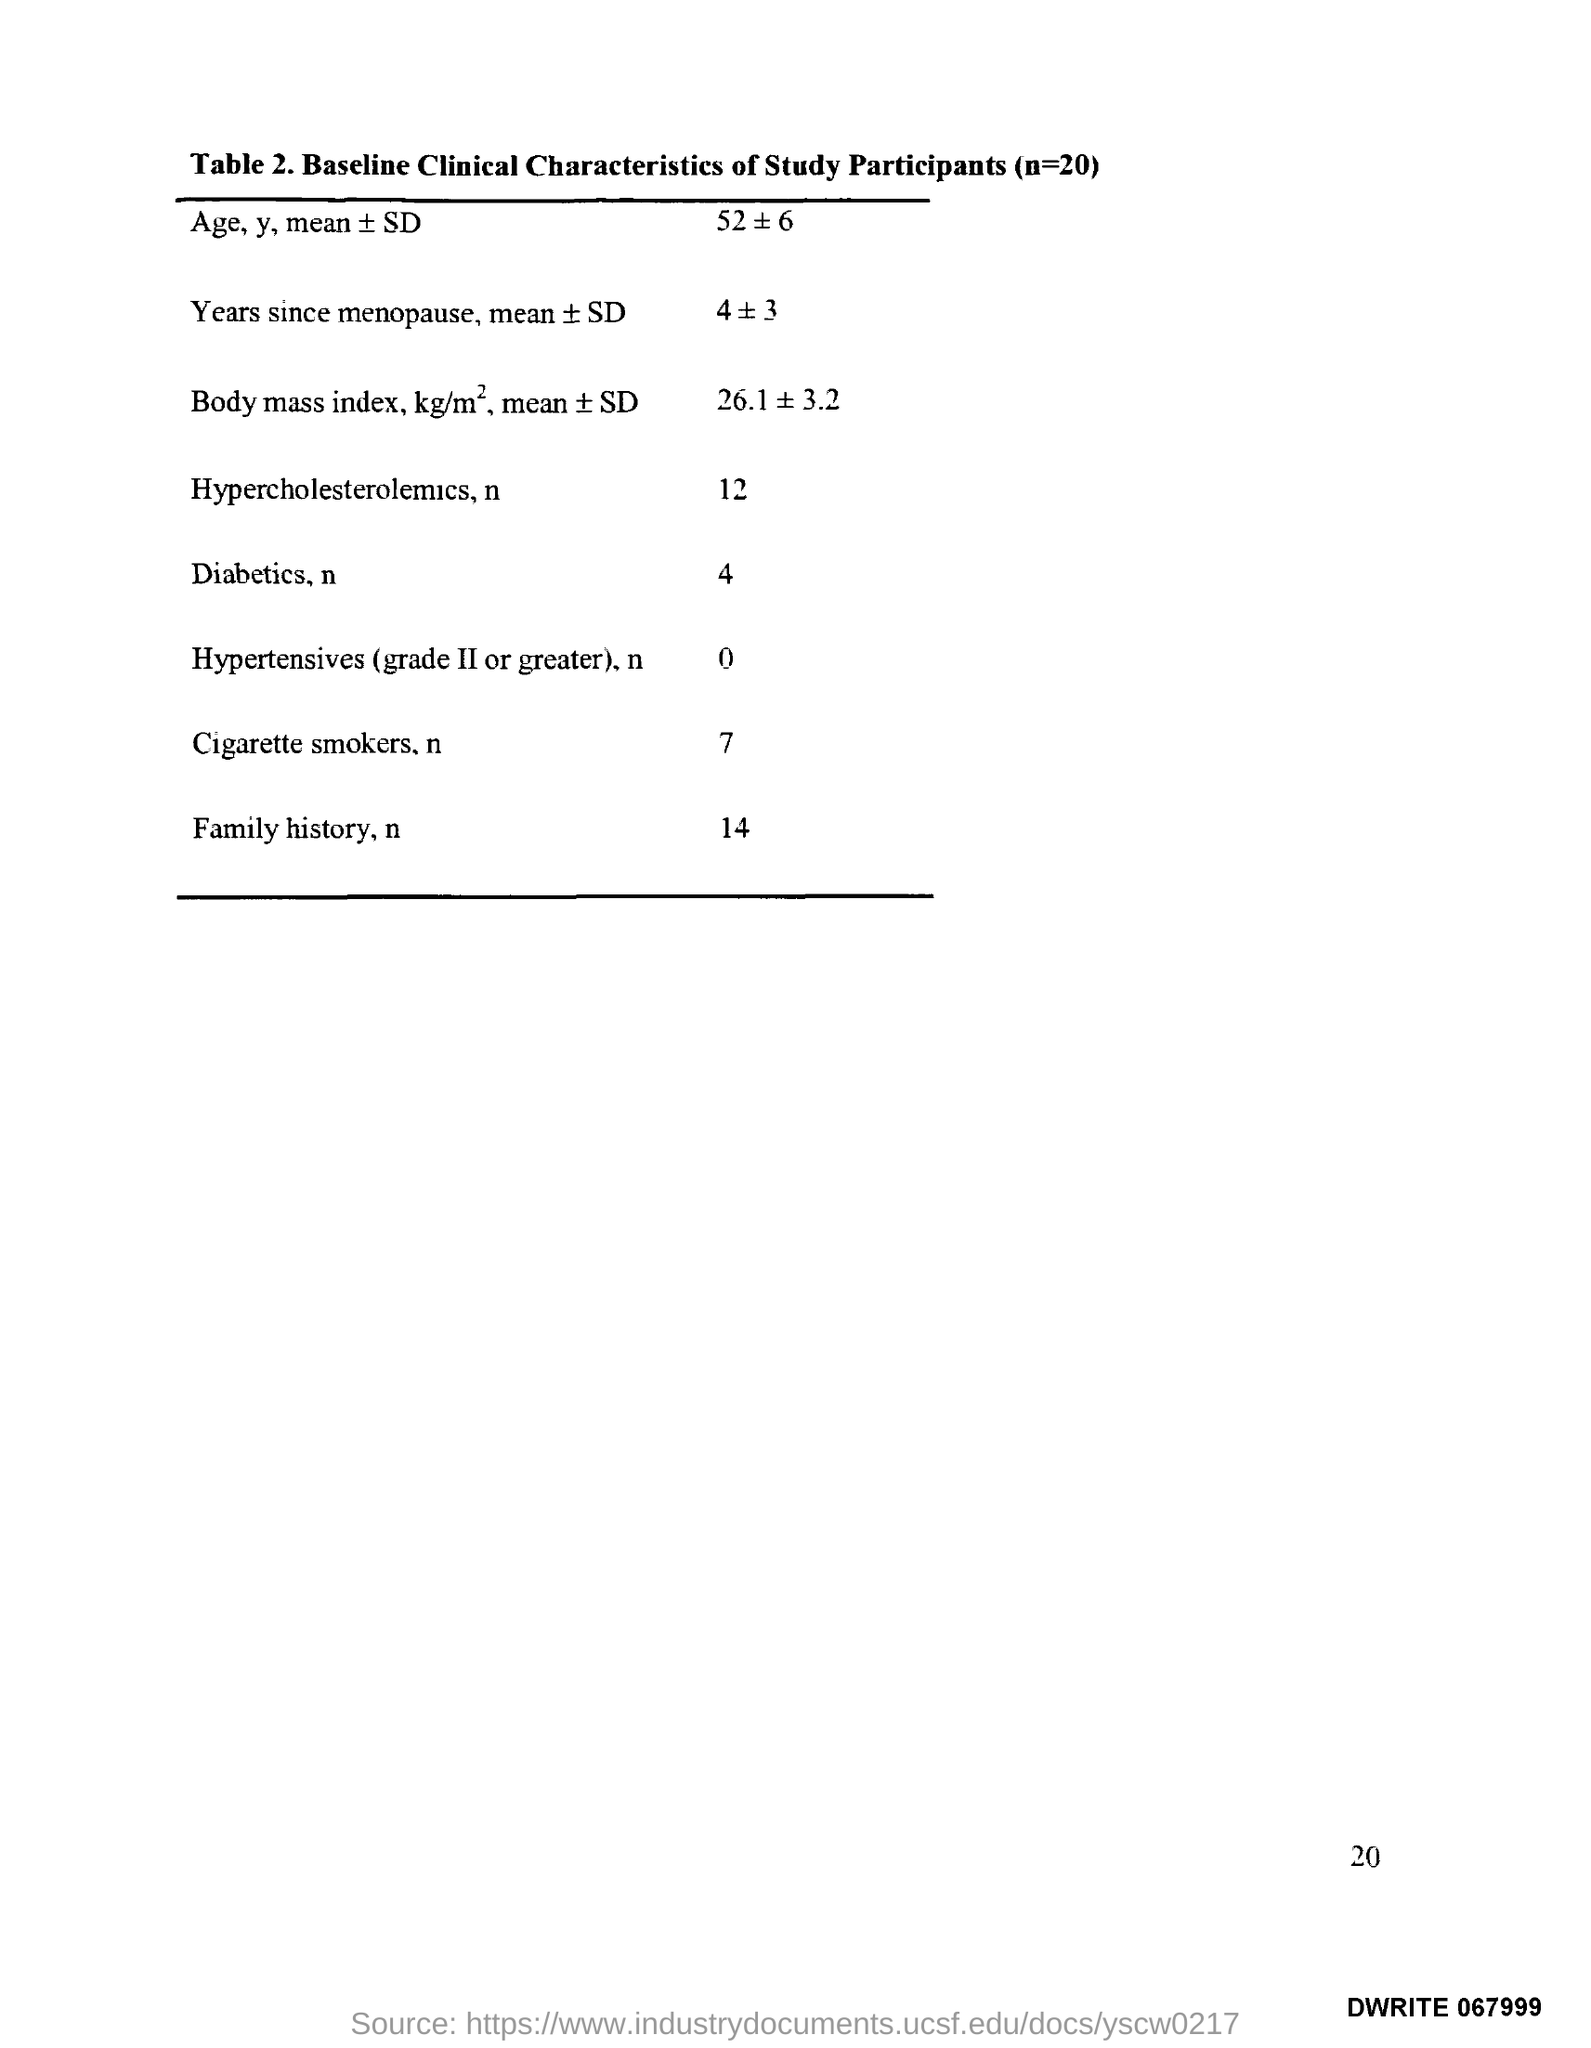What does Table 2. in this document describe?
Provide a succinct answer. Baseline Clinical Characteristics of Study Participants (n=20). 